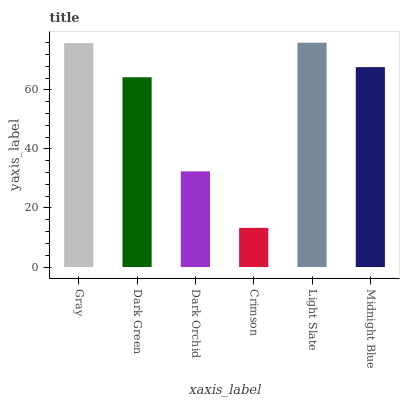Is Crimson the minimum?
Answer yes or no. Yes. Is Light Slate the maximum?
Answer yes or no. Yes. Is Dark Green the minimum?
Answer yes or no. No. Is Dark Green the maximum?
Answer yes or no. No. Is Gray greater than Dark Green?
Answer yes or no. Yes. Is Dark Green less than Gray?
Answer yes or no. Yes. Is Dark Green greater than Gray?
Answer yes or no. No. Is Gray less than Dark Green?
Answer yes or no. No. Is Midnight Blue the high median?
Answer yes or no. Yes. Is Dark Green the low median?
Answer yes or no. Yes. Is Dark Green the high median?
Answer yes or no. No. Is Crimson the low median?
Answer yes or no. No. 